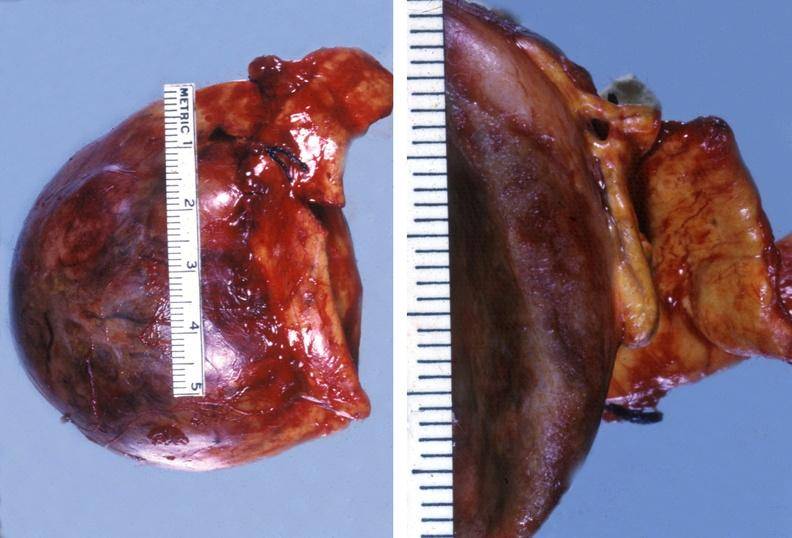what is present?
Answer the question using a single word or phrase. Endocrine 